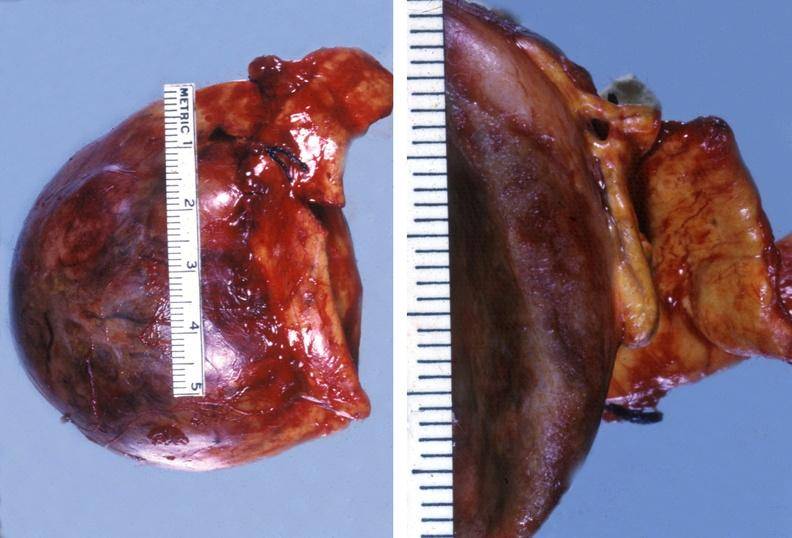what is present?
Answer the question using a single word or phrase. Endocrine 